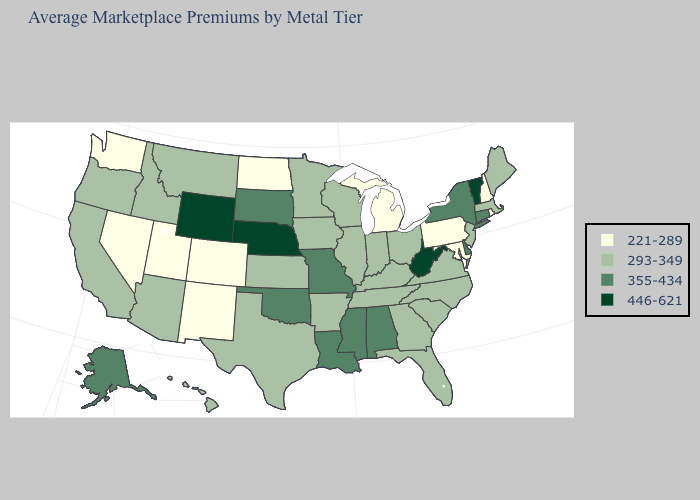What is the value of Nevada?
Keep it brief. 221-289. Name the states that have a value in the range 355-434?
Be succinct. Alabama, Alaska, Connecticut, Delaware, Louisiana, Mississippi, Missouri, New York, Oklahoma, South Dakota. What is the value of Delaware?
Write a very short answer. 355-434. Does Iowa have the highest value in the USA?
Give a very brief answer. No. How many symbols are there in the legend?
Quick response, please. 4. What is the value of Wyoming?
Quick response, please. 446-621. What is the value of Arkansas?
Answer briefly. 293-349. Name the states that have a value in the range 221-289?
Concise answer only. Colorado, Maryland, Michigan, Nevada, New Hampshire, New Mexico, North Dakota, Pennsylvania, Rhode Island, Utah, Washington. Does New Hampshire have the lowest value in the Northeast?
Short answer required. Yes. What is the value of Florida?
Quick response, please. 293-349. What is the value of Maryland?
Write a very short answer. 221-289. Name the states that have a value in the range 293-349?
Keep it brief. Arizona, Arkansas, California, Florida, Georgia, Hawaii, Idaho, Illinois, Indiana, Iowa, Kansas, Kentucky, Maine, Massachusetts, Minnesota, Montana, New Jersey, North Carolina, Ohio, Oregon, South Carolina, Tennessee, Texas, Virginia, Wisconsin. What is the value of Iowa?
Keep it brief. 293-349. Among the states that border Louisiana , does Arkansas have the highest value?
Write a very short answer. No. What is the lowest value in states that border Maryland?
Quick response, please. 221-289. 